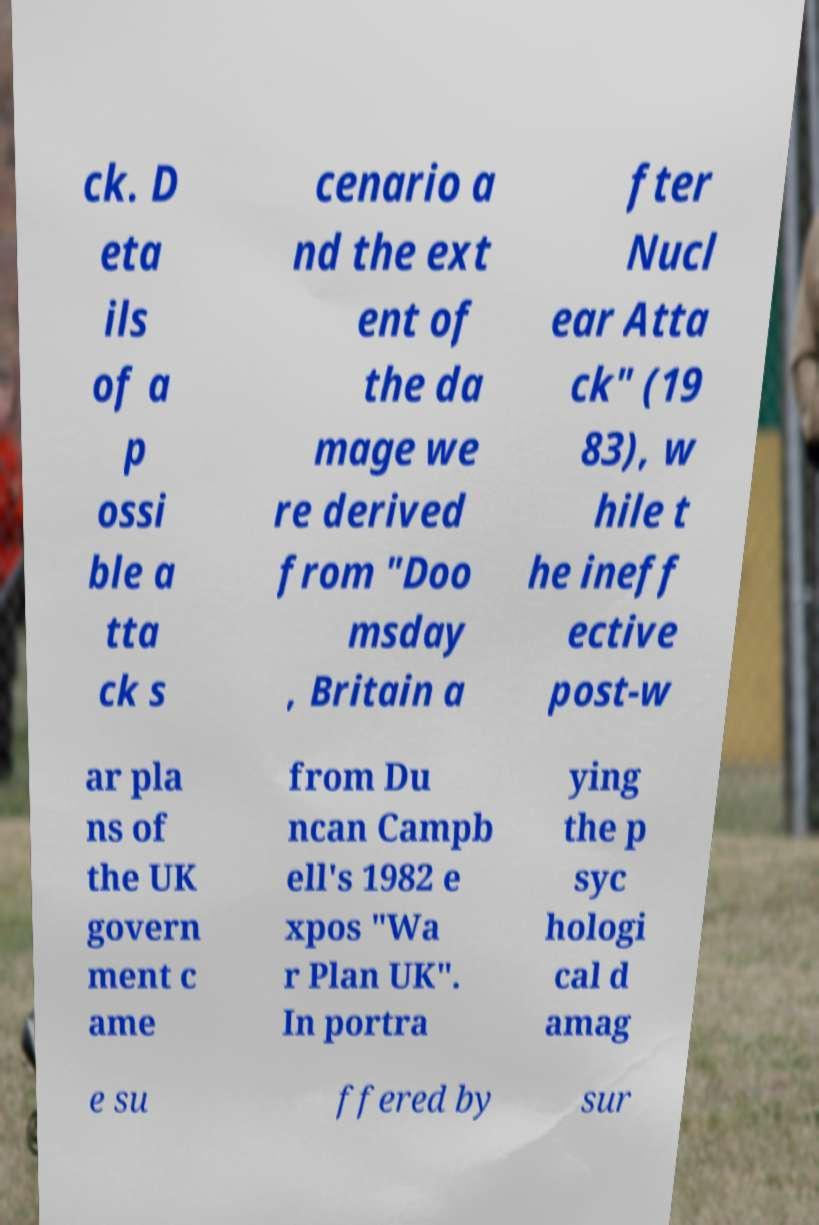Please identify and transcribe the text found in this image. ck. D eta ils of a p ossi ble a tta ck s cenario a nd the ext ent of the da mage we re derived from "Doo msday , Britain a fter Nucl ear Atta ck" (19 83), w hile t he ineff ective post-w ar pla ns of the UK govern ment c ame from Du ncan Campb ell's 1982 e xpos "Wa r Plan UK". In portra ying the p syc hologi cal d amag e su ffered by sur 